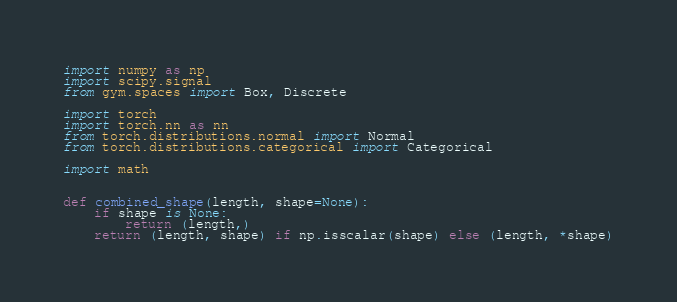<code> <loc_0><loc_0><loc_500><loc_500><_Python_>import numpy as np
import scipy.signal
from gym.spaces import Box, Discrete

import torch
import torch.nn as nn
from torch.distributions.normal import Normal
from torch.distributions.categorical import Categorical

import math


def combined_shape(length, shape=None):
    if shape is None:
        return (length,)
    return (length, shape) if np.isscalar(shape) else (length, *shape)

</code> 